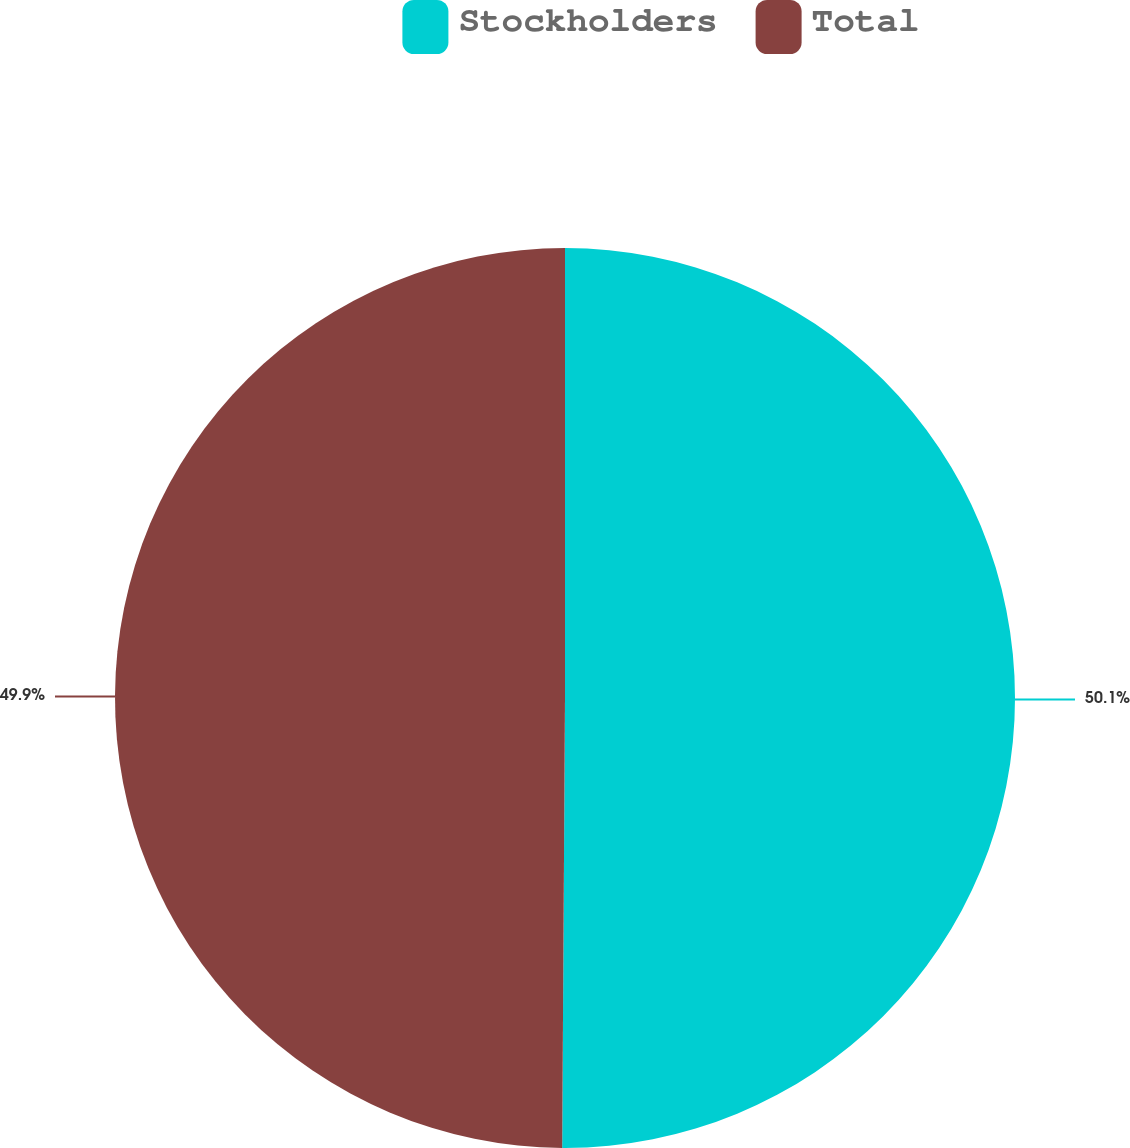Convert chart. <chart><loc_0><loc_0><loc_500><loc_500><pie_chart><fcel>Stockholders<fcel>Total<nl><fcel>50.1%<fcel>49.9%<nl></chart> 